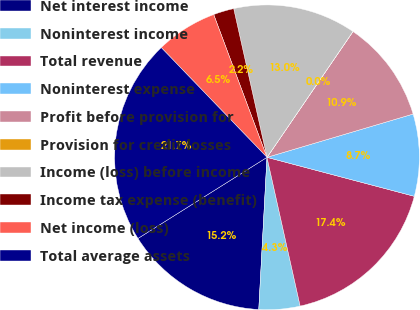Convert chart. <chart><loc_0><loc_0><loc_500><loc_500><pie_chart><fcel>Net interest income<fcel>Noninterest income<fcel>Total revenue<fcel>Noninterest expense<fcel>Profit before provision for<fcel>Provision for credit losses<fcel>Income (loss) before income<fcel>Income tax expense (benefit)<fcel>Net income (loss)<fcel>Total average assets<nl><fcel>15.21%<fcel>4.35%<fcel>17.39%<fcel>8.7%<fcel>10.87%<fcel>0.01%<fcel>13.04%<fcel>2.18%<fcel>6.52%<fcel>21.73%<nl></chart> 